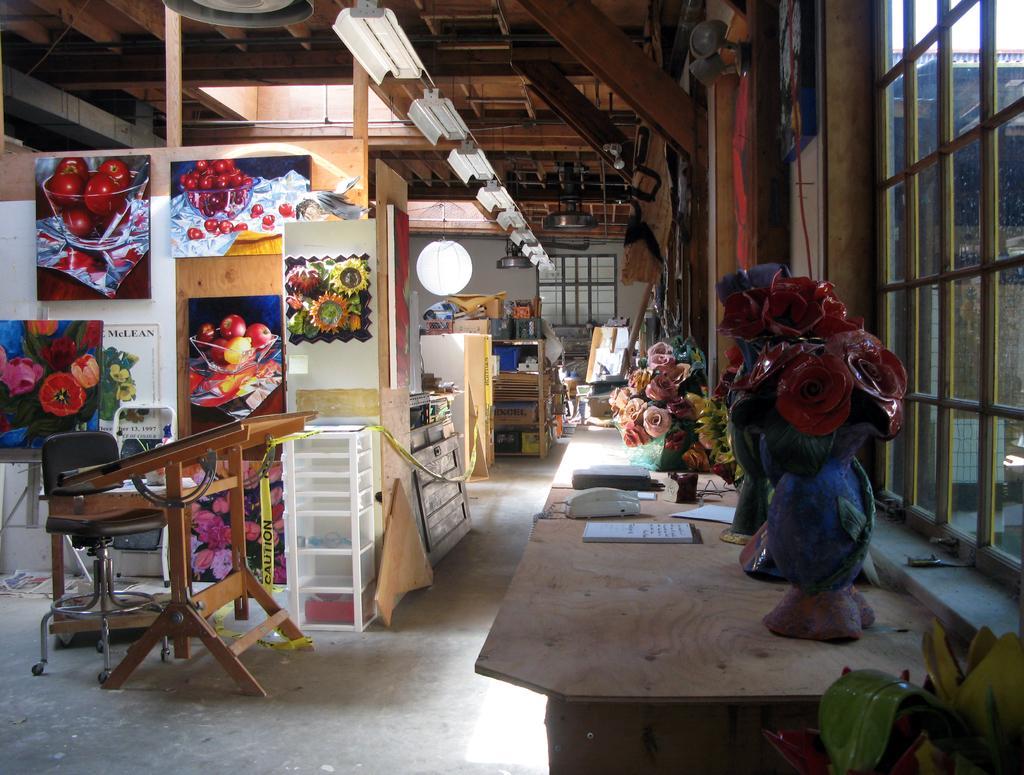Describe this image in one or two sentences. In the image we can see flower pot and a wooden table. On it there is a book and other objects. Here we can see chair, posters, floor, glass window and the lights. Here we can roof, made up of wood. 